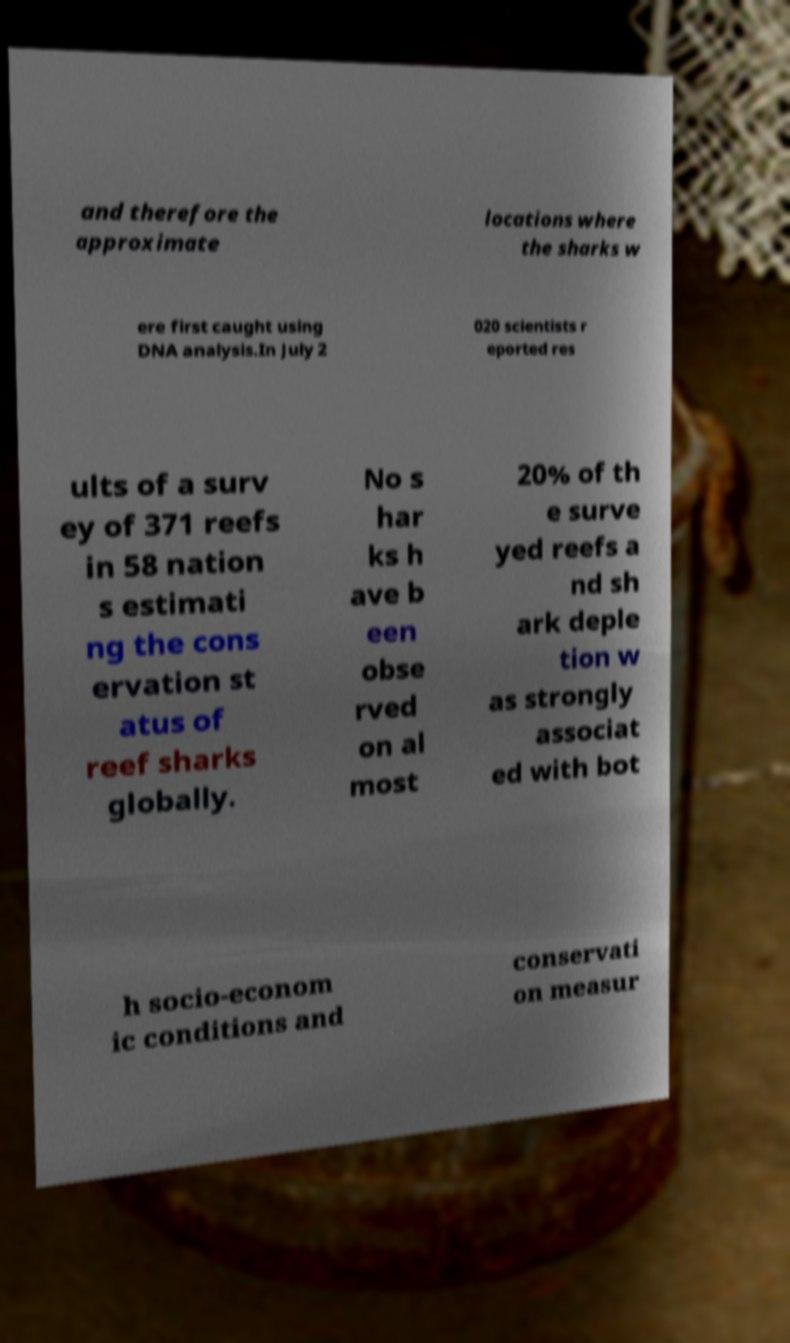Could you extract and type out the text from this image? and therefore the approximate locations where the sharks w ere first caught using DNA analysis.In July 2 020 scientists r eported res ults of a surv ey of 371 reefs in 58 nation s estimati ng the cons ervation st atus of reef sharks globally. No s har ks h ave b een obse rved on al most 20% of th e surve yed reefs a nd sh ark deple tion w as strongly associat ed with bot h socio-econom ic conditions and conservati on measur 